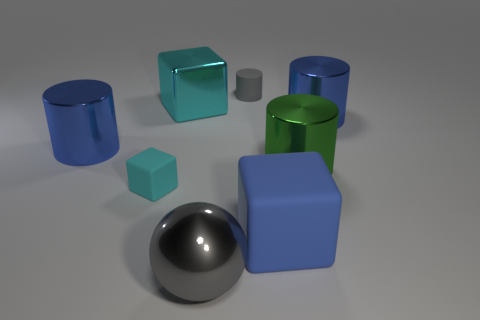Can you tell me which objects are reflective? Certainly! The sphere in the center is highly reflective; it's like a polished metal ball. Also, the cylinders and the blue blocks have a degree of reflectiveness, although to a lesser extent than the sphere. 